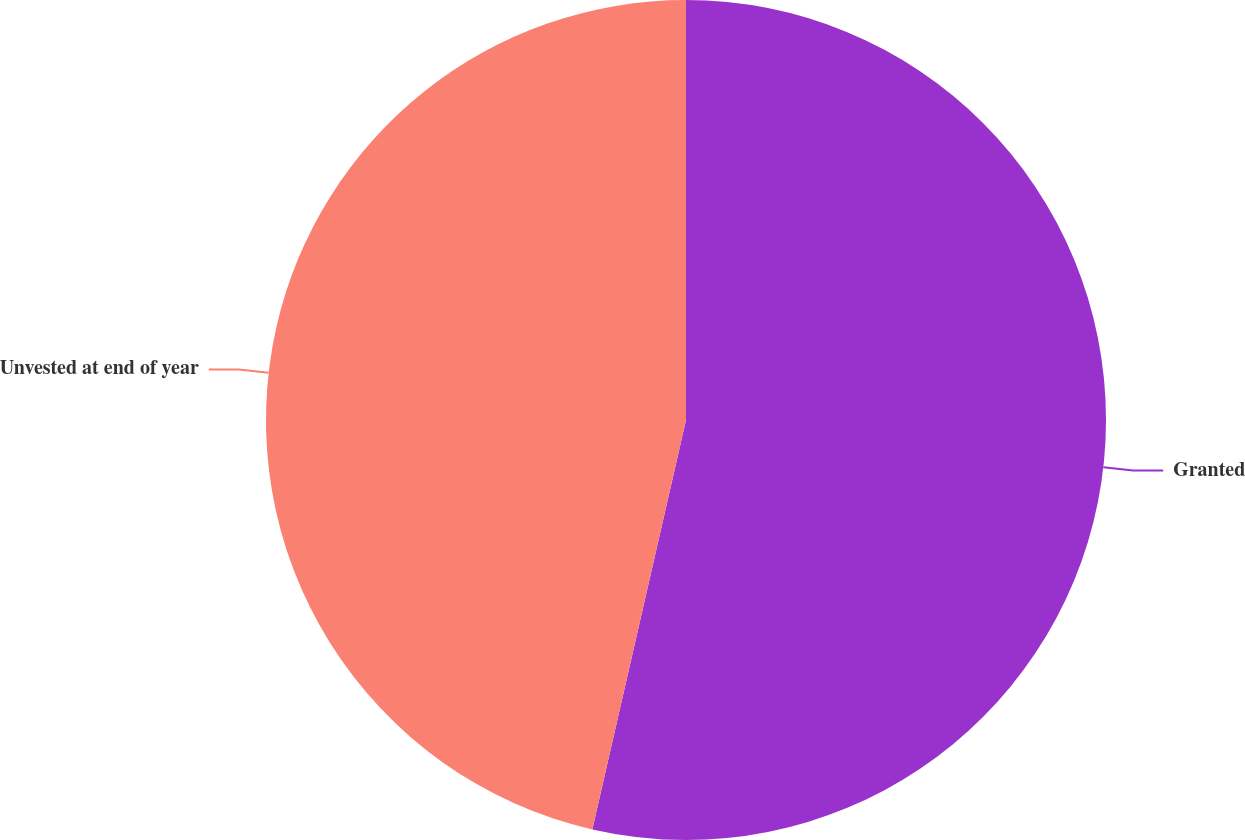Convert chart to OTSL. <chart><loc_0><loc_0><loc_500><loc_500><pie_chart><fcel>Granted<fcel>Unvested at end of year<nl><fcel>53.58%<fcel>46.42%<nl></chart> 